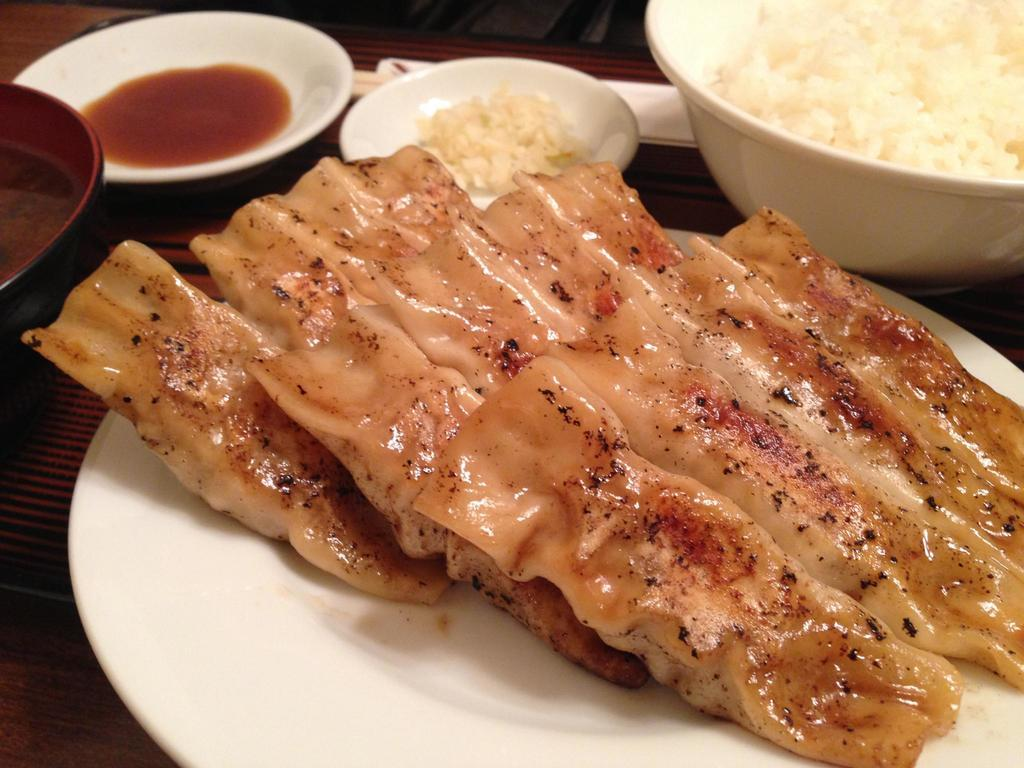What is the main food item visible on a plate in the image? The specific food item is not mentioned, but there is a food item on a plate in the image. What else is present on the plate besides the food item? The facts do not mention anything else on the plate. What other dish or container is visible in the image? There is a bowl in the image. What type of setting is depicted in the image? The image shows a table in the background, suggesting a dining or food-related setting. What caption is written on the notebook in the image? There is no notebook present in the image, so there is no caption to be read. 